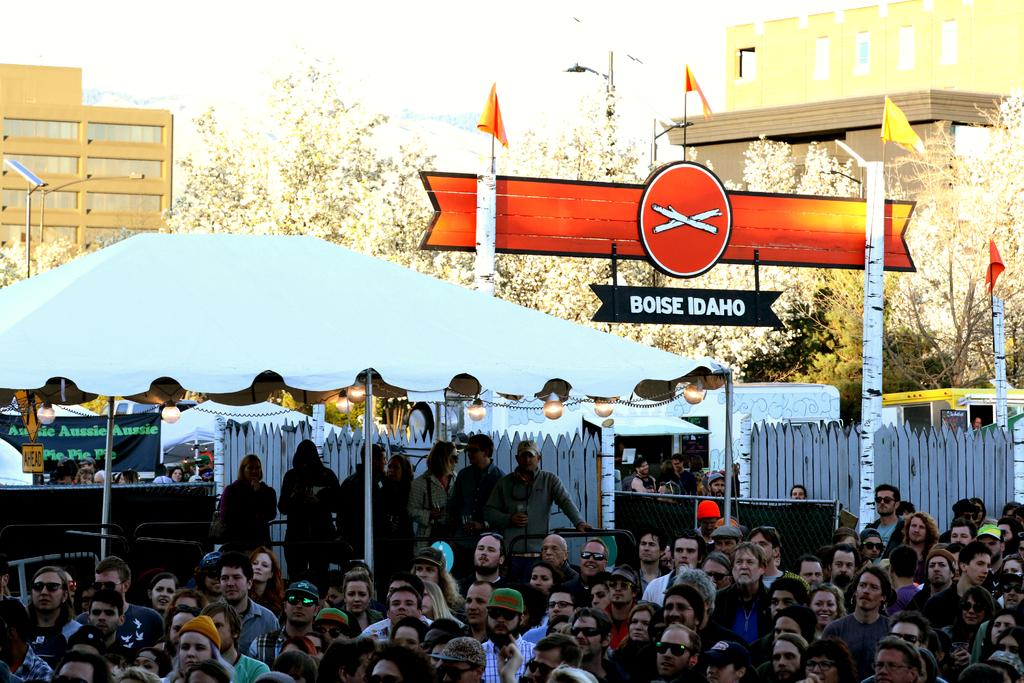How many people can be seen in the image? There are many people sitting in the image. What are the people doing in the image? The people are looking in a particular direction. What can be seen in the background of the image? There is a tent, trees, and buildings visible in the background of the image. What type of thunder can be heard in the image? There is no thunder present in the image, as it is a visual representation and does not include sound. 